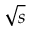<formula> <loc_0><loc_0><loc_500><loc_500>\sqrt { s }</formula> 